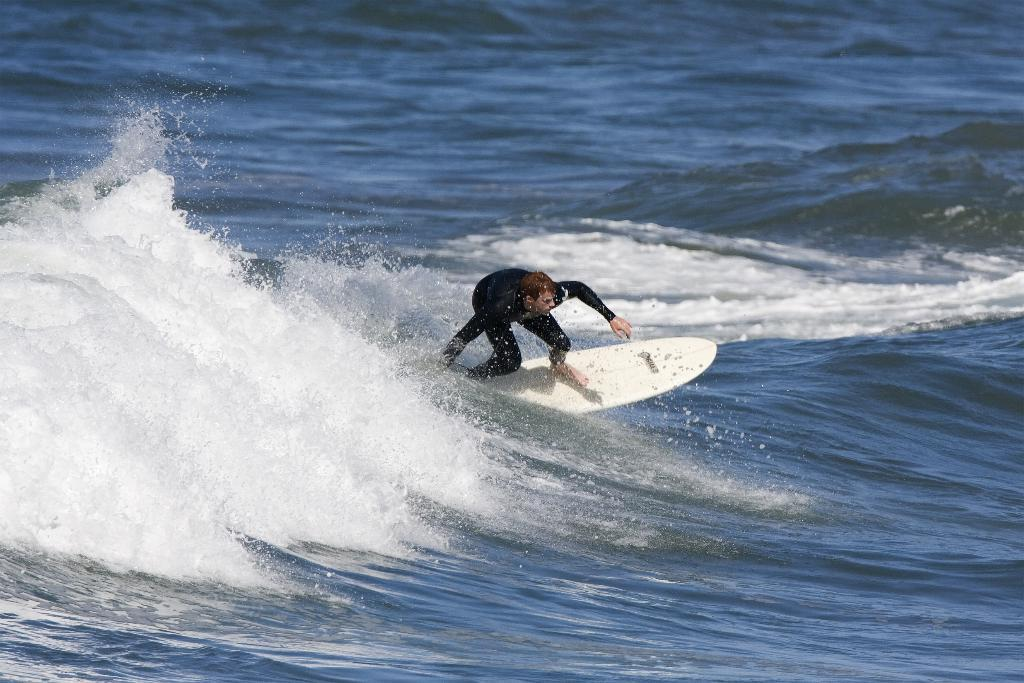Who is the main subject in the image? There is a man in the image. What is the man doing in the image? The man is surfing in an ocean. What object is the man using to surf? There is a white surfboard in the image. What is the man wearing while surfing? The man is wearing a black dress. How many wounds can be seen on the man's body in the image? There are no visible wounds on the man's body in the image. What type of conversation is the man having with the ocean in the image? The image does not depict the man talking to the ocean, so it is not possible to determine the content of any conversation. 